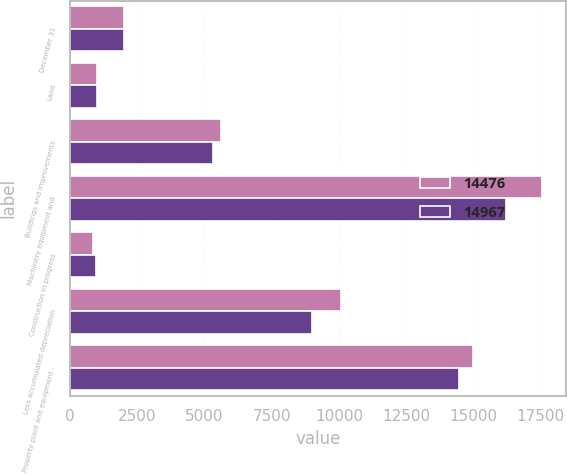Convert chart to OTSL. <chart><loc_0><loc_0><loc_500><loc_500><stacked_bar_chart><ecel><fcel>December 31<fcel>Land<fcel>Buildings and improvements<fcel>Machinery equipment and<fcel>Construction in progress<fcel>Less accumulated depreciation<fcel>Property plant and equipment -<nl><fcel>14476<fcel>2013<fcel>1011<fcel>5605<fcel>17551<fcel>865<fcel>10065<fcel>14967<nl><fcel>14967<fcel>2012<fcel>997<fcel>5307<fcel>16203<fcel>979<fcel>9010<fcel>14476<nl></chart> 